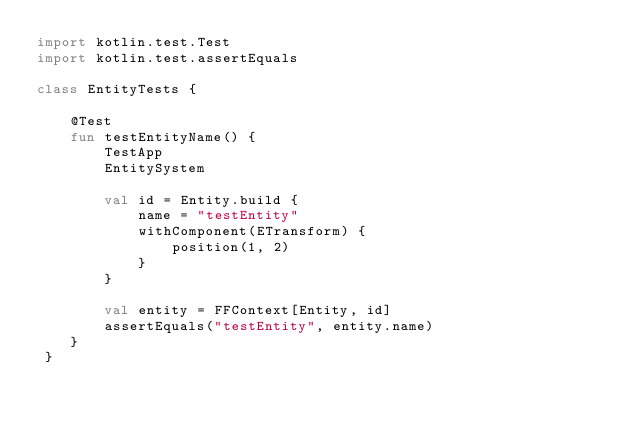Convert code to text. <code><loc_0><loc_0><loc_500><loc_500><_Kotlin_>import kotlin.test.Test
import kotlin.test.assertEquals

class EntityTests {

    @Test
    fun testEntityName() {
        TestApp
        EntitySystem

        val id = Entity.build {
            name = "testEntity"
            withComponent(ETransform) {
                position(1, 2)
            }
        }

        val entity = FFContext[Entity, id]
        assertEquals("testEntity", entity.name)
    }
 }</code> 